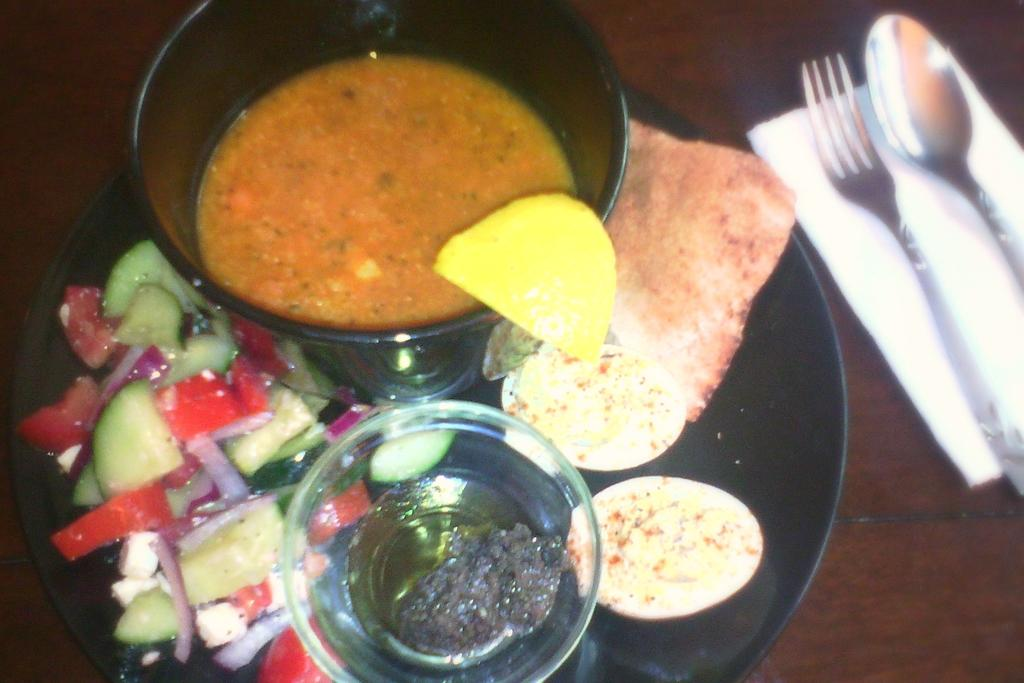What is placed on the black color plate in the image? There are food items on a black color plate in the image. How many bowls are present in the image? There are two bowls in the image. What utensil can be seen in the image? A spoon is visible in the image. What other utensil is present in the image? A fork is present in the image. What might be used for cleaning or wiping in the image? Tissue is observable in the image. What is the color of the table in the image? The table in the image is brown in color. How many trees are visible in the image? There are no trees visible in the image. What type of bird can be seen sitting on the fork in the image? There is no bird present in the image, and the fork is not depicted as having a bird on it. 